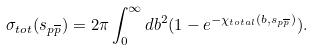<formula> <loc_0><loc_0><loc_500><loc_500>\sigma _ { t o t } ( s _ { p \overline { p } } ) = 2 \pi \int _ { 0 } ^ { \infty } d b ^ { 2 } ( 1 - e ^ { - \chi _ { t o t a l } ( b , s _ { p \overline { p } } ) } ) .</formula> 